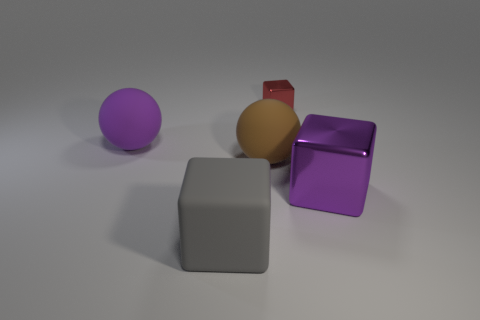Subtract all purple blocks. Subtract all cyan balls. How many blocks are left? 2 Add 4 tiny red objects. How many objects exist? 9 Subtract all cubes. How many objects are left? 2 Add 2 big brown spheres. How many big brown spheres exist? 3 Subtract 1 gray cubes. How many objects are left? 4 Subtract all large blue rubber balls. Subtract all large purple balls. How many objects are left? 4 Add 1 gray matte blocks. How many gray matte blocks are left? 2 